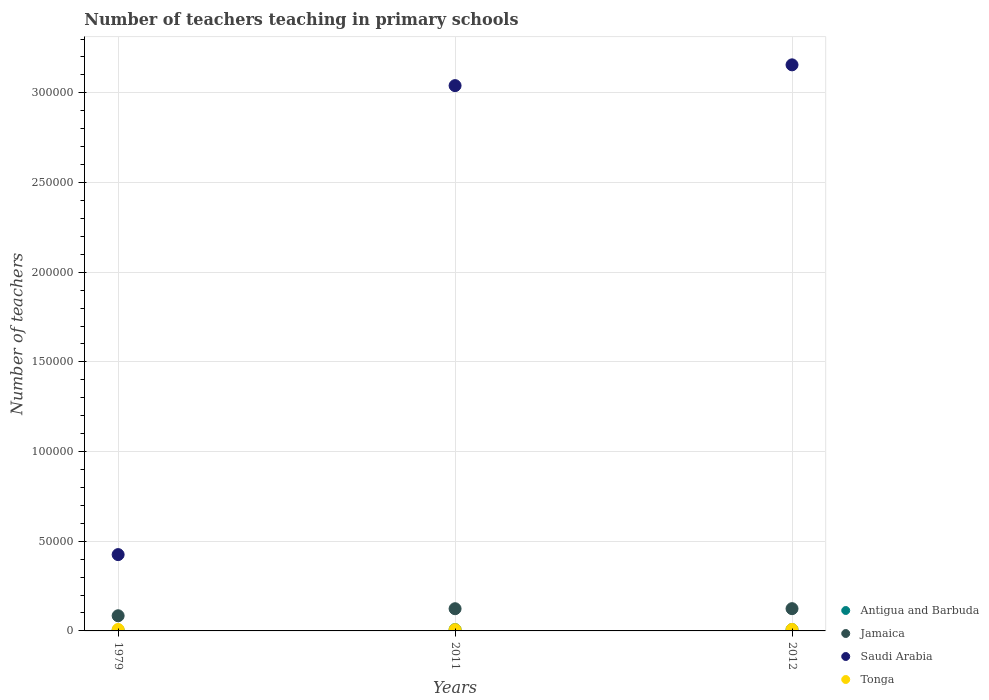Is the number of dotlines equal to the number of legend labels?
Keep it short and to the point. Yes. What is the number of teachers teaching in primary schools in Saudi Arabia in 2011?
Provide a short and direct response. 3.04e+05. Across all years, what is the maximum number of teachers teaching in primary schools in Antigua and Barbuda?
Provide a succinct answer. 755. Across all years, what is the minimum number of teachers teaching in primary schools in Saudi Arabia?
Keep it short and to the point. 4.26e+04. What is the total number of teachers teaching in primary schools in Saudi Arabia in the graph?
Give a very brief answer. 6.62e+05. What is the difference between the number of teachers teaching in primary schools in Jamaica in 1979 and that in 2012?
Provide a short and direct response. -3956. What is the difference between the number of teachers teaching in primary schools in Tonga in 1979 and the number of teachers teaching in primary schools in Saudi Arabia in 2012?
Ensure brevity in your answer.  -3.15e+05. What is the average number of teachers teaching in primary schools in Jamaica per year?
Keep it short and to the point. 1.11e+04. In the year 2011, what is the difference between the number of teachers teaching in primary schools in Jamaica and number of teachers teaching in primary schools in Saudi Arabia?
Your response must be concise. -2.92e+05. What is the ratio of the number of teachers teaching in primary schools in Antigua and Barbuda in 2011 to that in 2012?
Your answer should be compact. 0.99. Is the difference between the number of teachers teaching in primary schools in Jamaica in 1979 and 2011 greater than the difference between the number of teachers teaching in primary schools in Saudi Arabia in 1979 and 2011?
Offer a terse response. Yes. What is the difference between the highest and the second highest number of teachers teaching in primary schools in Tonga?
Your answer should be compact. 2. What is the difference between the highest and the lowest number of teachers teaching in primary schools in Tonga?
Give a very brief answer. 112. In how many years, is the number of teachers teaching in primary schools in Saudi Arabia greater than the average number of teachers teaching in primary schools in Saudi Arabia taken over all years?
Give a very brief answer. 2. Is the sum of the number of teachers teaching in primary schools in Saudi Arabia in 2011 and 2012 greater than the maximum number of teachers teaching in primary schools in Tonga across all years?
Ensure brevity in your answer.  Yes. Is it the case that in every year, the sum of the number of teachers teaching in primary schools in Antigua and Barbuda and number of teachers teaching in primary schools in Jamaica  is greater than the sum of number of teachers teaching in primary schools in Saudi Arabia and number of teachers teaching in primary schools in Tonga?
Your response must be concise. No. Does the number of teachers teaching in primary schools in Jamaica monotonically increase over the years?
Ensure brevity in your answer.  Yes. Is the number of teachers teaching in primary schools in Saudi Arabia strictly less than the number of teachers teaching in primary schools in Tonga over the years?
Your answer should be very brief. No. How many dotlines are there?
Provide a short and direct response. 4. What is the difference between two consecutive major ticks on the Y-axis?
Ensure brevity in your answer.  5.00e+04. Where does the legend appear in the graph?
Offer a terse response. Bottom right. How are the legend labels stacked?
Provide a short and direct response. Vertical. What is the title of the graph?
Your response must be concise. Number of teachers teaching in primary schools. What is the label or title of the Y-axis?
Offer a very short reply. Number of teachers. What is the Number of teachers of Antigua and Barbuda in 1979?
Provide a short and direct response. 390. What is the Number of teachers of Jamaica in 1979?
Offer a very short reply. 8453. What is the Number of teachers in Saudi Arabia in 1979?
Offer a very short reply. 4.26e+04. What is the Number of teachers in Tonga in 1979?
Your response must be concise. 818. What is the Number of teachers in Antigua and Barbuda in 2011?
Your response must be concise. 748. What is the Number of teachers of Jamaica in 2011?
Offer a terse response. 1.24e+04. What is the Number of teachers of Saudi Arabia in 2011?
Provide a succinct answer. 3.04e+05. What is the Number of teachers of Tonga in 2011?
Provide a succinct answer. 706. What is the Number of teachers of Antigua and Barbuda in 2012?
Keep it short and to the point. 755. What is the Number of teachers in Jamaica in 2012?
Ensure brevity in your answer.  1.24e+04. What is the Number of teachers of Saudi Arabia in 2012?
Your answer should be very brief. 3.16e+05. What is the Number of teachers of Tonga in 2012?
Offer a terse response. 816. Across all years, what is the maximum Number of teachers in Antigua and Barbuda?
Your response must be concise. 755. Across all years, what is the maximum Number of teachers in Jamaica?
Make the answer very short. 1.24e+04. Across all years, what is the maximum Number of teachers in Saudi Arabia?
Make the answer very short. 3.16e+05. Across all years, what is the maximum Number of teachers of Tonga?
Ensure brevity in your answer.  818. Across all years, what is the minimum Number of teachers in Antigua and Barbuda?
Offer a terse response. 390. Across all years, what is the minimum Number of teachers of Jamaica?
Offer a terse response. 8453. Across all years, what is the minimum Number of teachers in Saudi Arabia?
Your response must be concise. 4.26e+04. Across all years, what is the minimum Number of teachers in Tonga?
Provide a succinct answer. 706. What is the total Number of teachers of Antigua and Barbuda in the graph?
Ensure brevity in your answer.  1893. What is the total Number of teachers in Jamaica in the graph?
Keep it short and to the point. 3.32e+04. What is the total Number of teachers of Saudi Arabia in the graph?
Offer a terse response. 6.62e+05. What is the total Number of teachers in Tonga in the graph?
Provide a short and direct response. 2340. What is the difference between the Number of teachers of Antigua and Barbuda in 1979 and that in 2011?
Give a very brief answer. -358. What is the difference between the Number of teachers in Jamaica in 1979 and that in 2011?
Provide a succinct answer. -3927. What is the difference between the Number of teachers of Saudi Arabia in 1979 and that in 2011?
Provide a succinct answer. -2.61e+05. What is the difference between the Number of teachers in Tonga in 1979 and that in 2011?
Offer a terse response. 112. What is the difference between the Number of teachers in Antigua and Barbuda in 1979 and that in 2012?
Provide a succinct answer. -365. What is the difference between the Number of teachers in Jamaica in 1979 and that in 2012?
Your answer should be compact. -3956. What is the difference between the Number of teachers of Saudi Arabia in 1979 and that in 2012?
Provide a short and direct response. -2.73e+05. What is the difference between the Number of teachers in Tonga in 1979 and that in 2012?
Offer a very short reply. 2. What is the difference between the Number of teachers in Antigua and Barbuda in 2011 and that in 2012?
Offer a very short reply. -7. What is the difference between the Number of teachers in Saudi Arabia in 2011 and that in 2012?
Make the answer very short. -1.16e+04. What is the difference between the Number of teachers of Tonga in 2011 and that in 2012?
Offer a terse response. -110. What is the difference between the Number of teachers in Antigua and Barbuda in 1979 and the Number of teachers in Jamaica in 2011?
Provide a short and direct response. -1.20e+04. What is the difference between the Number of teachers of Antigua and Barbuda in 1979 and the Number of teachers of Saudi Arabia in 2011?
Make the answer very short. -3.04e+05. What is the difference between the Number of teachers in Antigua and Barbuda in 1979 and the Number of teachers in Tonga in 2011?
Offer a very short reply. -316. What is the difference between the Number of teachers in Jamaica in 1979 and the Number of teachers in Saudi Arabia in 2011?
Give a very brief answer. -2.96e+05. What is the difference between the Number of teachers of Jamaica in 1979 and the Number of teachers of Tonga in 2011?
Your response must be concise. 7747. What is the difference between the Number of teachers of Saudi Arabia in 1979 and the Number of teachers of Tonga in 2011?
Your response must be concise. 4.18e+04. What is the difference between the Number of teachers of Antigua and Barbuda in 1979 and the Number of teachers of Jamaica in 2012?
Ensure brevity in your answer.  -1.20e+04. What is the difference between the Number of teachers in Antigua and Barbuda in 1979 and the Number of teachers in Saudi Arabia in 2012?
Give a very brief answer. -3.15e+05. What is the difference between the Number of teachers of Antigua and Barbuda in 1979 and the Number of teachers of Tonga in 2012?
Your answer should be compact. -426. What is the difference between the Number of teachers of Jamaica in 1979 and the Number of teachers of Saudi Arabia in 2012?
Ensure brevity in your answer.  -3.07e+05. What is the difference between the Number of teachers of Jamaica in 1979 and the Number of teachers of Tonga in 2012?
Provide a succinct answer. 7637. What is the difference between the Number of teachers of Saudi Arabia in 1979 and the Number of teachers of Tonga in 2012?
Your response must be concise. 4.17e+04. What is the difference between the Number of teachers of Antigua and Barbuda in 2011 and the Number of teachers of Jamaica in 2012?
Your response must be concise. -1.17e+04. What is the difference between the Number of teachers in Antigua and Barbuda in 2011 and the Number of teachers in Saudi Arabia in 2012?
Offer a very short reply. -3.15e+05. What is the difference between the Number of teachers in Antigua and Barbuda in 2011 and the Number of teachers in Tonga in 2012?
Ensure brevity in your answer.  -68. What is the difference between the Number of teachers in Jamaica in 2011 and the Number of teachers in Saudi Arabia in 2012?
Your answer should be very brief. -3.03e+05. What is the difference between the Number of teachers of Jamaica in 2011 and the Number of teachers of Tonga in 2012?
Provide a succinct answer. 1.16e+04. What is the difference between the Number of teachers in Saudi Arabia in 2011 and the Number of teachers in Tonga in 2012?
Your response must be concise. 3.03e+05. What is the average Number of teachers in Antigua and Barbuda per year?
Your answer should be very brief. 631. What is the average Number of teachers in Jamaica per year?
Keep it short and to the point. 1.11e+04. What is the average Number of teachers in Saudi Arabia per year?
Make the answer very short. 2.21e+05. What is the average Number of teachers of Tonga per year?
Provide a succinct answer. 780. In the year 1979, what is the difference between the Number of teachers in Antigua and Barbuda and Number of teachers in Jamaica?
Give a very brief answer. -8063. In the year 1979, what is the difference between the Number of teachers in Antigua and Barbuda and Number of teachers in Saudi Arabia?
Provide a succinct answer. -4.22e+04. In the year 1979, what is the difference between the Number of teachers of Antigua and Barbuda and Number of teachers of Tonga?
Ensure brevity in your answer.  -428. In the year 1979, what is the difference between the Number of teachers in Jamaica and Number of teachers in Saudi Arabia?
Your answer should be compact. -3.41e+04. In the year 1979, what is the difference between the Number of teachers in Jamaica and Number of teachers in Tonga?
Your response must be concise. 7635. In the year 1979, what is the difference between the Number of teachers of Saudi Arabia and Number of teachers of Tonga?
Offer a terse response. 4.17e+04. In the year 2011, what is the difference between the Number of teachers in Antigua and Barbuda and Number of teachers in Jamaica?
Provide a succinct answer. -1.16e+04. In the year 2011, what is the difference between the Number of teachers of Antigua and Barbuda and Number of teachers of Saudi Arabia?
Your answer should be compact. -3.03e+05. In the year 2011, what is the difference between the Number of teachers in Antigua and Barbuda and Number of teachers in Tonga?
Your answer should be compact. 42. In the year 2011, what is the difference between the Number of teachers of Jamaica and Number of teachers of Saudi Arabia?
Offer a terse response. -2.92e+05. In the year 2011, what is the difference between the Number of teachers of Jamaica and Number of teachers of Tonga?
Provide a succinct answer. 1.17e+04. In the year 2011, what is the difference between the Number of teachers of Saudi Arabia and Number of teachers of Tonga?
Make the answer very short. 3.03e+05. In the year 2012, what is the difference between the Number of teachers in Antigua and Barbuda and Number of teachers in Jamaica?
Keep it short and to the point. -1.17e+04. In the year 2012, what is the difference between the Number of teachers in Antigua and Barbuda and Number of teachers in Saudi Arabia?
Provide a succinct answer. -3.15e+05. In the year 2012, what is the difference between the Number of teachers of Antigua and Barbuda and Number of teachers of Tonga?
Offer a very short reply. -61. In the year 2012, what is the difference between the Number of teachers of Jamaica and Number of teachers of Saudi Arabia?
Offer a terse response. -3.03e+05. In the year 2012, what is the difference between the Number of teachers in Jamaica and Number of teachers in Tonga?
Give a very brief answer. 1.16e+04. In the year 2012, what is the difference between the Number of teachers in Saudi Arabia and Number of teachers in Tonga?
Offer a very short reply. 3.15e+05. What is the ratio of the Number of teachers of Antigua and Barbuda in 1979 to that in 2011?
Your response must be concise. 0.52. What is the ratio of the Number of teachers of Jamaica in 1979 to that in 2011?
Your answer should be compact. 0.68. What is the ratio of the Number of teachers of Saudi Arabia in 1979 to that in 2011?
Offer a terse response. 0.14. What is the ratio of the Number of teachers of Tonga in 1979 to that in 2011?
Your answer should be compact. 1.16. What is the ratio of the Number of teachers of Antigua and Barbuda in 1979 to that in 2012?
Ensure brevity in your answer.  0.52. What is the ratio of the Number of teachers in Jamaica in 1979 to that in 2012?
Keep it short and to the point. 0.68. What is the ratio of the Number of teachers of Saudi Arabia in 1979 to that in 2012?
Your answer should be compact. 0.13. What is the ratio of the Number of teachers in Saudi Arabia in 2011 to that in 2012?
Make the answer very short. 0.96. What is the ratio of the Number of teachers in Tonga in 2011 to that in 2012?
Ensure brevity in your answer.  0.87. What is the difference between the highest and the second highest Number of teachers of Antigua and Barbuda?
Make the answer very short. 7. What is the difference between the highest and the second highest Number of teachers in Saudi Arabia?
Provide a succinct answer. 1.16e+04. What is the difference between the highest and the lowest Number of teachers in Antigua and Barbuda?
Provide a succinct answer. 365. What is the difference between the highest and the lowest Number of teachers of Jamaica?
Make the answer very short. 3956. What is the difference between the highest and the lowest Number of teachers of Saudi Arabia?
Your answer should be very brief. 2.73e+05. What is the difference between the highest and the lowest Number of teachers in Tonga?
Provide a succinct answer. 112. 